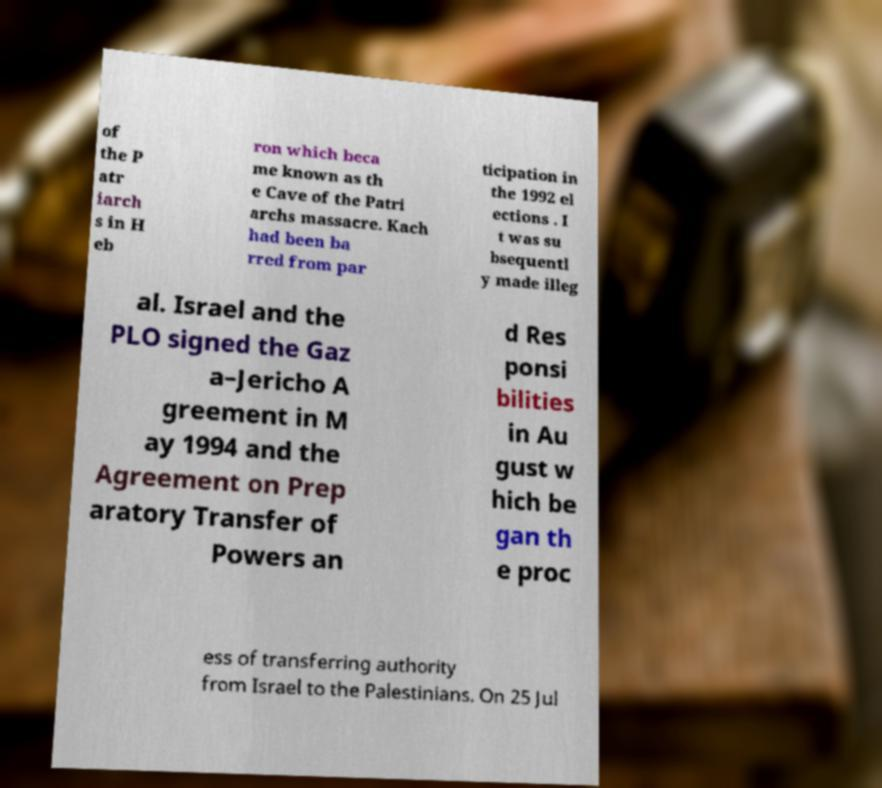There's text embedded in this image that I need extracted. Can you transcribe it verbatim? of the P atr iarch s in H eb ron which beca me known as th e Cave of the Patri archs massacre. Kach had been ba rred from par ticipation in the 1992 el ections . I t was su bsequentl y made illeg al. Israel and the PLO signed the Gaz a–Jericho A greement in M ay 1994 and the Agreement on Prep aratory Transfer of Powers an d Res ponsi bilities in Au gust w hich be gan th e proc ess of transferring authority from Israel to the Palestinians. On 25 Jul 